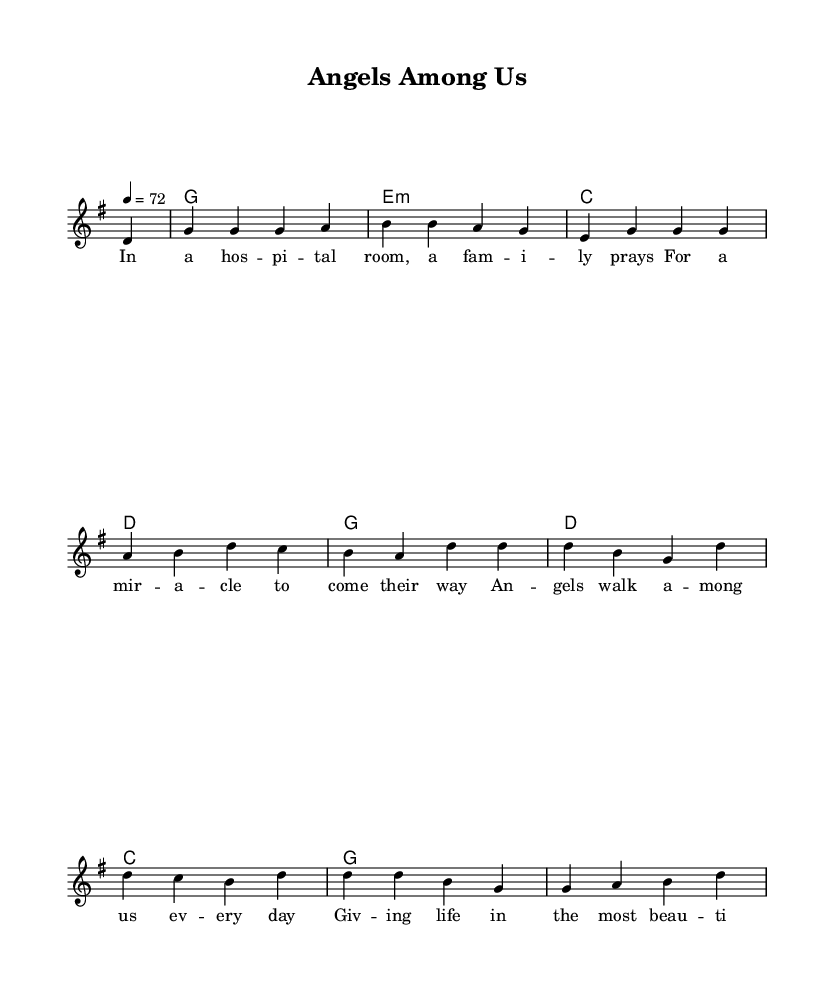What is the key signature of this music? The key signature is G major, which has one sharp (F#). This is determined by the "g" placed at the beginning of the staff.
Answer: G major What is the time signature of the piece? The time signature is four-four, which is indicated by the "4/4" shown at the beginning of the piece. This means there are four beats in each measure and the quarter note gets one beat.
Answer: Four-four What is the tempo marking? The tempo marking indicates a speed of 72 beats per minute, as shown by the "4 = 72" notation. This means that the quarter note is counted at a speed of 72 beats in one minute.
Answer: 72 beats per minute How many measures does the melody have? The melody consists of 10 measures, where each measure is separated by a vertical line, and the number of measures can be counted directly from the notation.
Answer: 10 measures What is the first note of the melody? The first note of the melody is D, which is indicated as the initial note after the partial measure mark.
Answer: D Name the harmony structure used in the song. The harmony structure mainly alternates between G major, E minor, C major, and D major, which are the chords listed sequentially in the chord section. These chords create the harmonic foundation for the melody.
Answer: G, E minor, C, D 